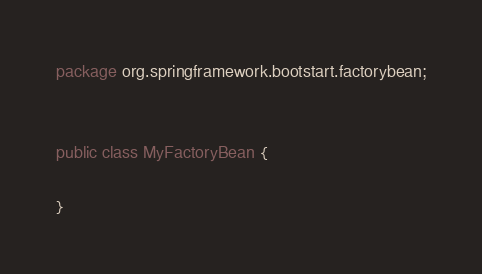Convert code to text. <code><loc_0><loc_0><loc_500><loc_500><_Java_>package org.springframework.bootstart.factorybean;


public class MyFactoryBean {

}
</code> 